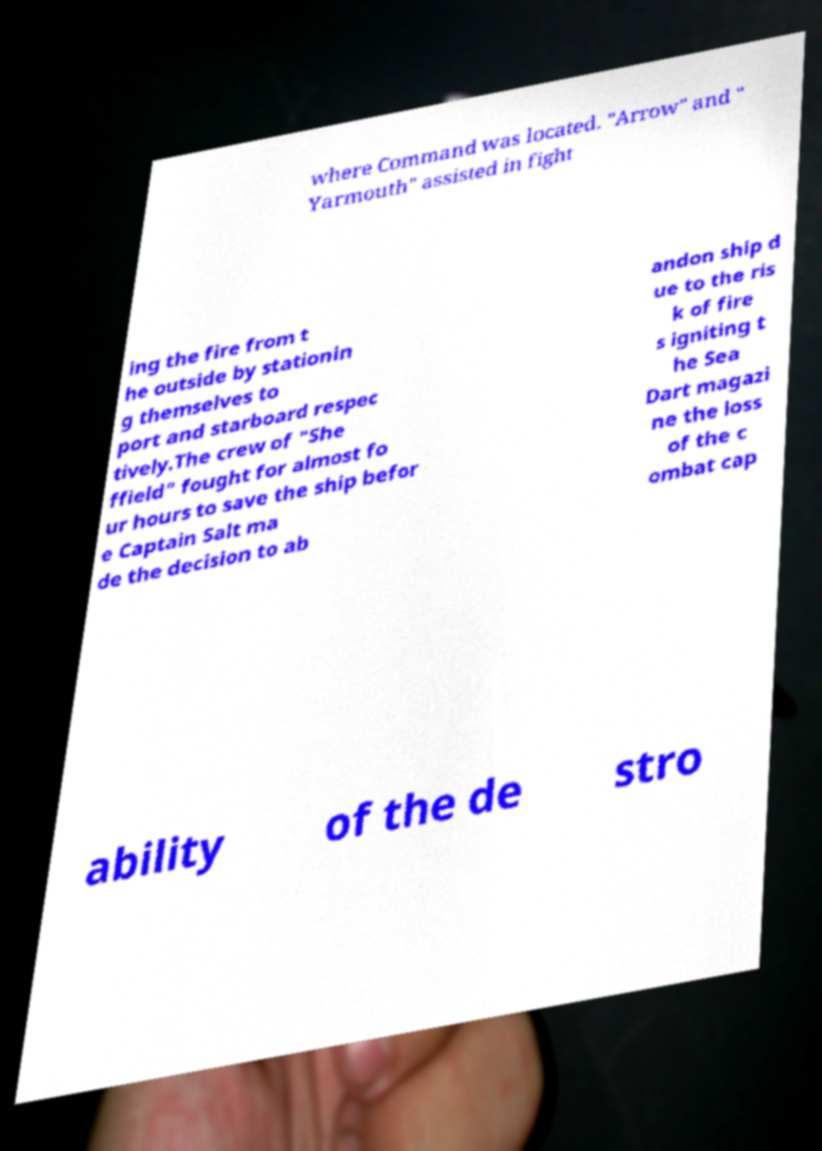For documentation purposes, I need the text within this image transcribed. Could you provide that? where Command was located. "Arrow" and " Yarmouth" assisted in fight ing the fire from t he outside by stationin g themselves to port and starboard respec tively.The crew of "She ffield" fought for almost fo ur hours to save the ship befor e Captain Salt ma de the decision to ab andon ship d ue to the ris k of fire s igniting t he Sea Dart magazi ne the loss of the c ombat cap ability of the de stro 